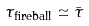<formula> <loc_0><loc_0><loc_500><loc_500>\tau _ { \text {fireball} } \simeq \bar { \tau }</formula> 